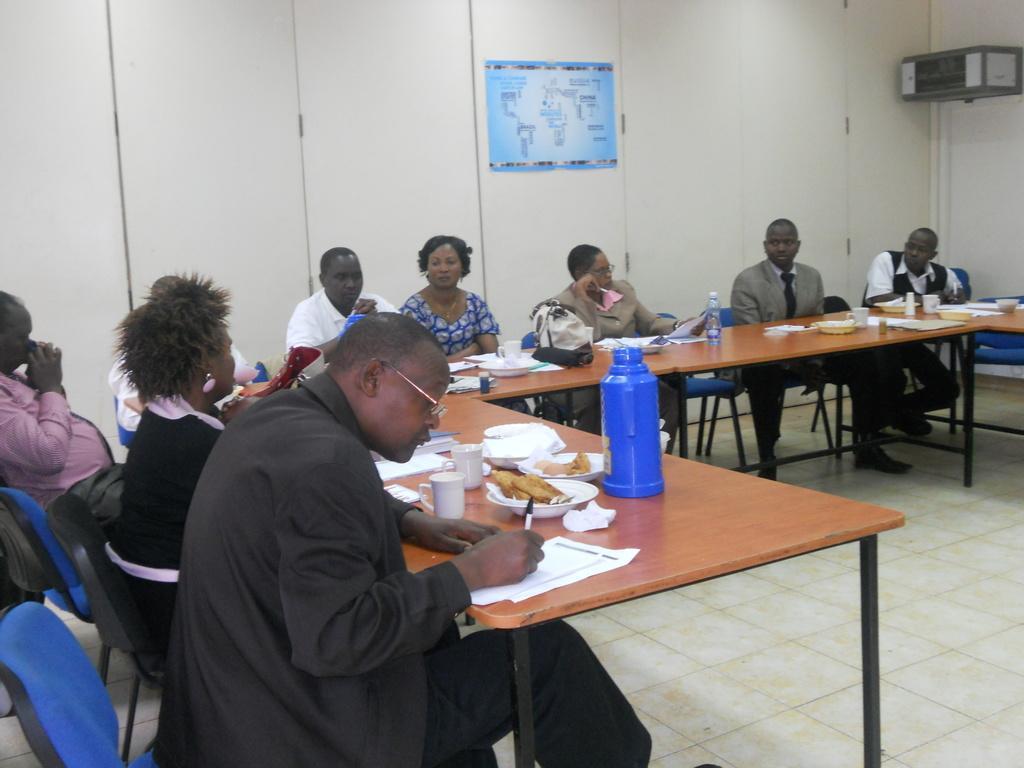In one or two sentences, can you explain what this image depicts? A group of people are sitting on the chair and in the left a man is writing on the paper. 